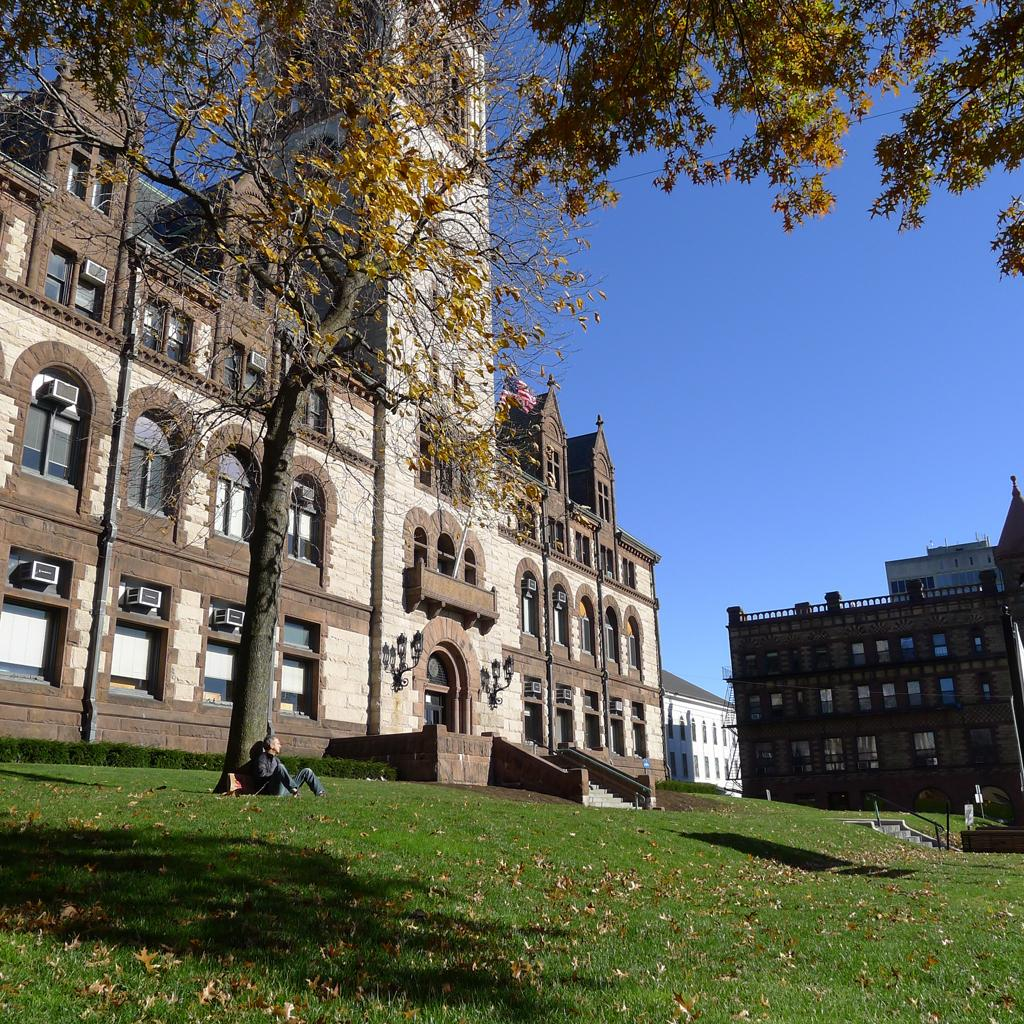What is the person in the image doing? There is a person sitting in the image. What type of natural environment is visible in the image? There is grass and trees in the image. What type of artificial structures can be seen in the image? There are lights, buildings, and air conditioners in the image. What can be seen in the background of the image? The sky is visible in the background of the image. Can you see the ocean in the image? No, there is no ocean visible in the image. Is the person wearing a hat in the image? The provided facts do not mention a hat, so we cannot determine if the person is wearing one. 